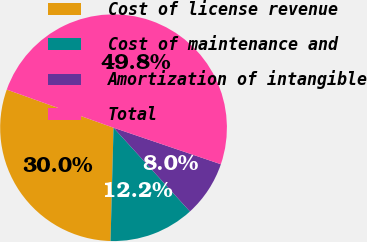Convert chart to OTSL. <chart><loc_0><loc_0><loc_500><loc_500><pie_chart><fcel>Cost of license revenue<fcel>Cost of maintenance and<fcel>Amortization of intangible<fcel>Total<nl><fcel>30.04%<fcel>12.19%<fcel>8.01%<fcel>49.77%<nl></chart> 